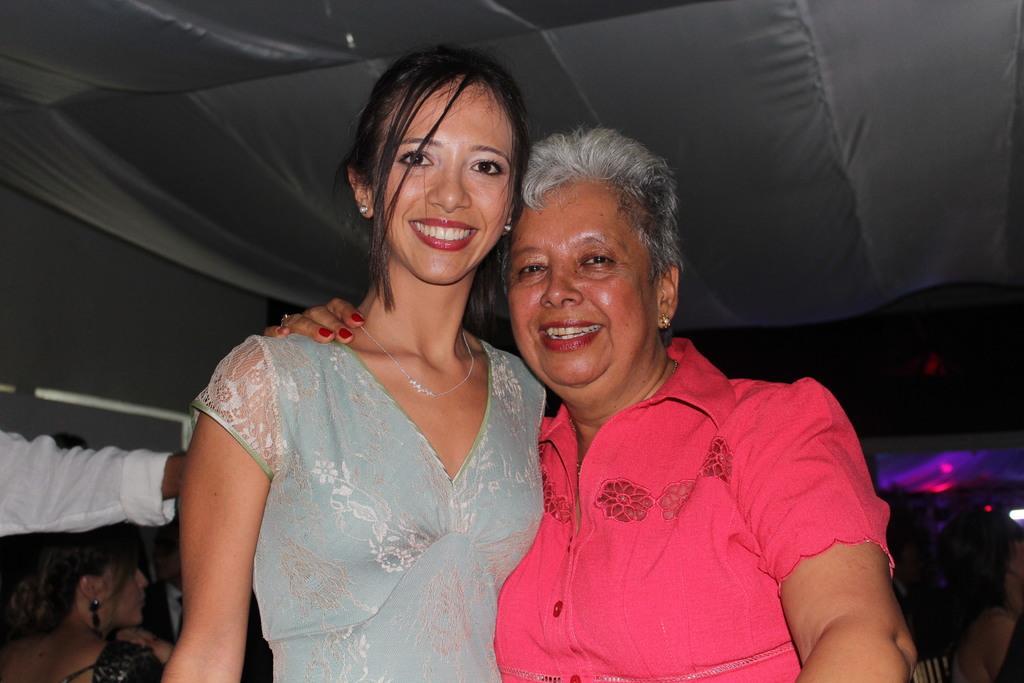How would you summarize this image in a sentence or two? In this image, we can see persons wearing clothes. There is a tent at the top of the image. 